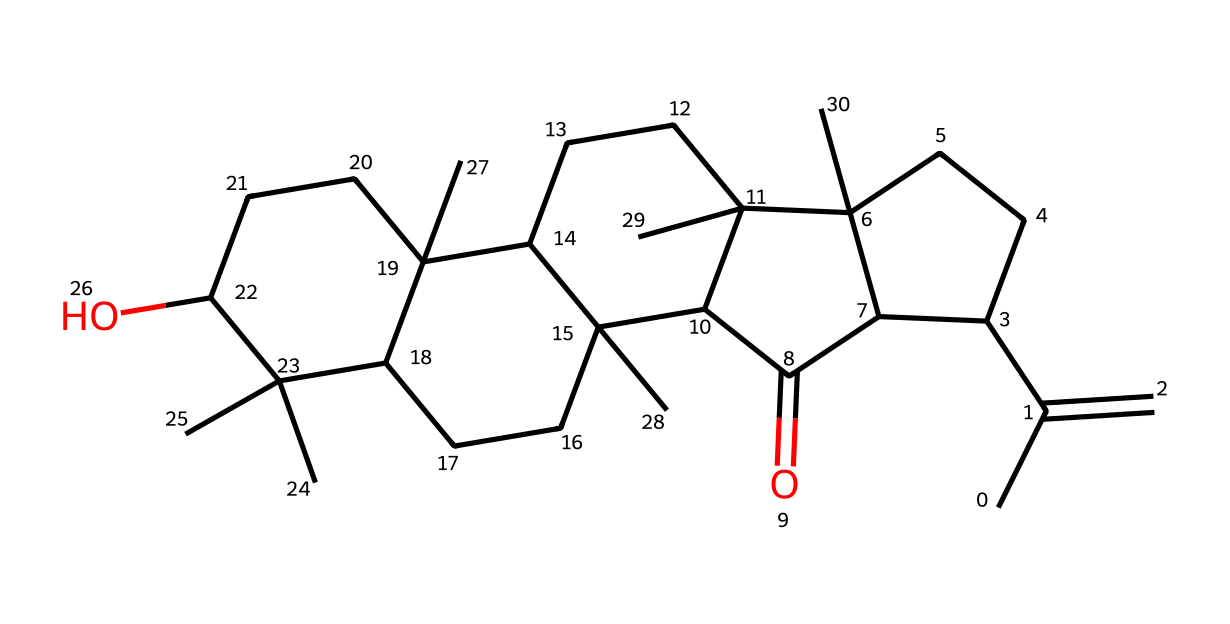What is the primary functional group present in this compound? The structure contains a hydroxyl group (–OH) indicated by the "C" connected to the "O," which is connected to an "H". This characteristic indicates the presence of alcohol functional groups.
Answer: hydroxyl How many cyclic structures are present in this molecule? By analyzing the SMILES, we can observe several instances of "C" connected in a cyclical arrangement indicating rings. In total, there are four distinct ring structures noted in the SMILES notation.
Answer: four What type of coordination compound could this substance form? Given the presence of hydroxyl groups and potential availability of electron pairs on the oxygen, this compound can act as a ligand, possibly forming a coordination complex with metal ions.
Answer: ligand What physical state is frankincense expected to have? The molecular arrangement and typical properties of similar compounds suggest a solid state at room temperature as it is a resin.
Answer: solid How many oxygen atoms are present in this structure? By counting the occurrences of “O” in the provided SMILES representation, we can determine that there are two oxygen atoms present in the structure.
Answer: two What type of bonding is primarily displayed in this chemical structure? This molecule primarily exhibits covalent bonding characterized by the presence of shared electrons between carbon and oxygen atoms.
Answer: covalent 